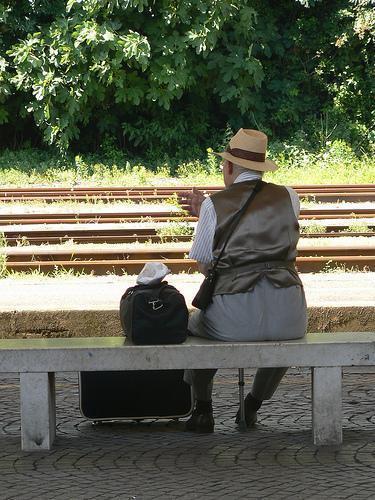How many bags does the man have with him?
Give a very brief answer. 2. How many sets of tracks are visible?
Give a very brief answer. 3. 